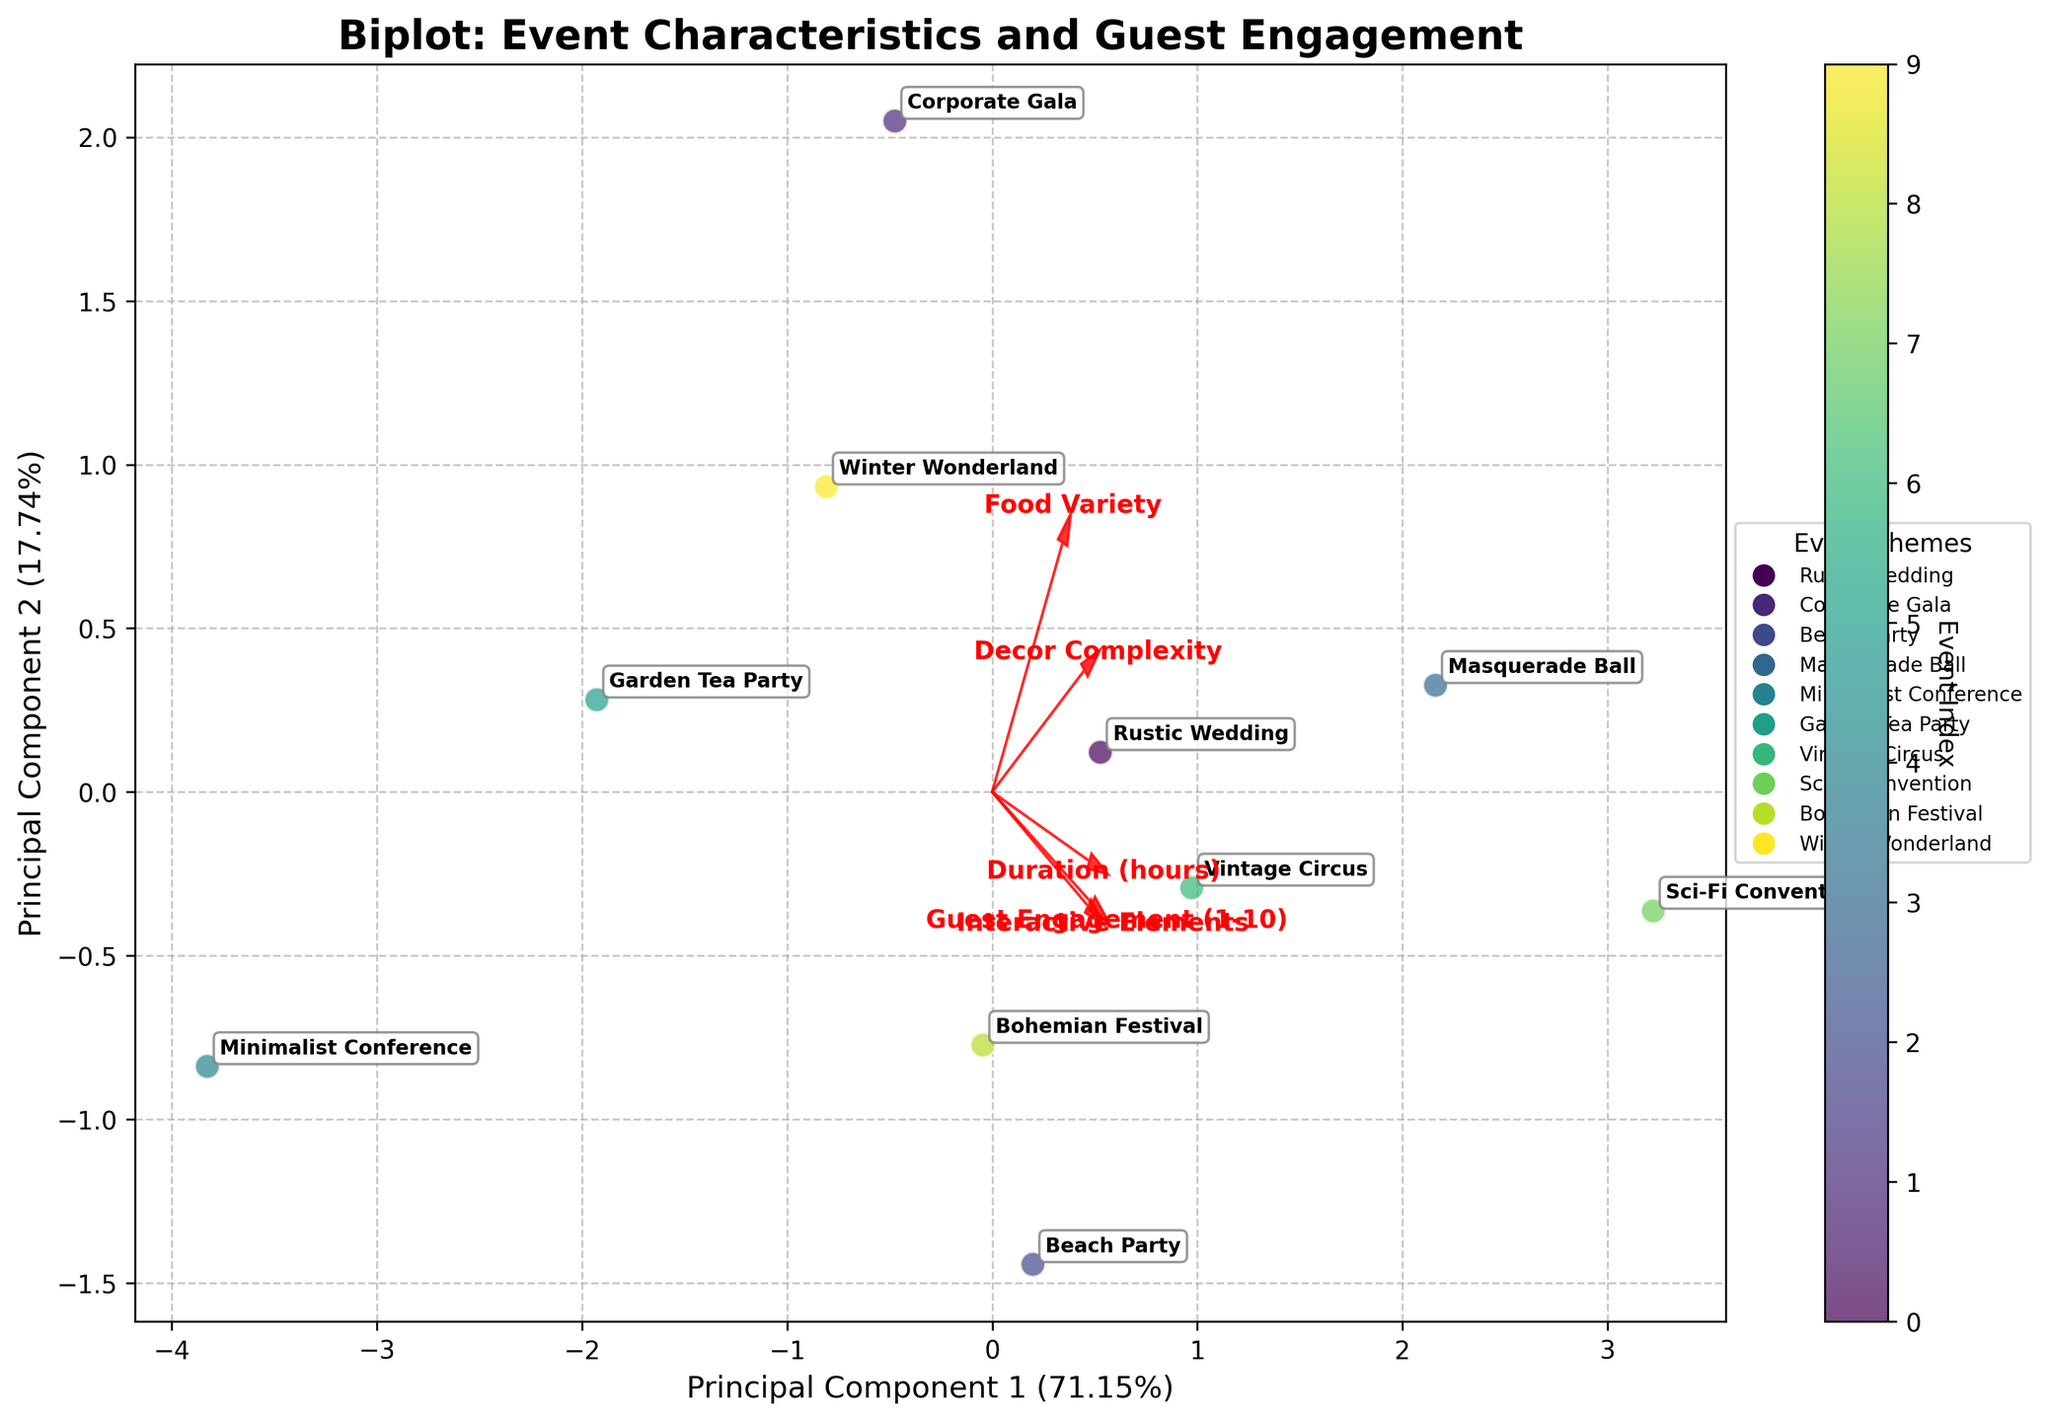What is the title of the plot? The title is displayed at the top of the plot and acts as a summary of what the plot is showing.
Answer: Biplot: Event Characteristics and Guest Engagement How many principal components are represented in the plot? The axes in the plot are labeled with Principal Component 1 and Principal Component 2, indicating that two principal components are represented.
Answer: 2 Which event theme has the highest guest engagement level according to the biplot? By observing the annotations near the data points, the event theme with the highest guest engagement level (closest to 10) is associated with the Sci-Fi Convention.
Answer: Sci-Fi Convention What percentage of the variance is explained by the first principal component? The x-axis label indicates the percentage of variance explained by Principal Component 1. It reads approximately 45.45%.
Answer: 45.45% Which features have vectors pointing in the same direction? By examining the directions of the arrows representing different features in the biplot, it's clear that "Guest Engagement (1-10)", "Interactive Elements", and "Decor Complexity" point roughly in the same direction, signifying positive correlation among them.
Answer: Guest Engagement, Interactive Elements, Decor Complexity Which two event themes appear closest on the biplot? The Garden Tea Party and Minimalist Conference are the closest to each other point-wise, indicating similar characteristics as reduced by PCA.
Answer: Garden Tea Party, Minimalist Conference What are the coordinates of the "Beach Party" event theme in the principal component space? By looking at the location of the scatter point labeled "Beach Party", its coordinates in the PC1 and PC2 dimensions are approximately (0.5, 1.5).
Answer: (0.5, 1.5) How do "Interactive Elements" and "Food Variety" compare in terms of their contribution to the principal components? Observing the lengths and directions of the vectors, the arrows for "Interactive Elements" and "Food Variety" show similar magnitudes but point in slightly different directions, indicating substantial contributions but different relationships to the PCs.
Answer: Similar magnitudes, different directions What type of relationship can be inferred between "Duration (hours)" and "Food Variety"? The arrow vectors for "Duration (hours)" and "Food Variety" point in nearly opposite directions, suggesting a negative correlation between these features according to the PCA results.
Answer: Negative correlation 